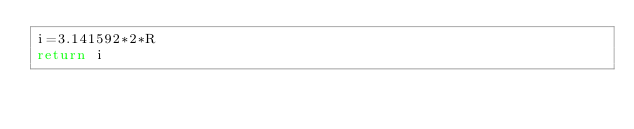Convert code to text. <code><loc_0><loc_0><loc_500><loc_500><_Python_>i=3.141592*2*R
return i</code> 